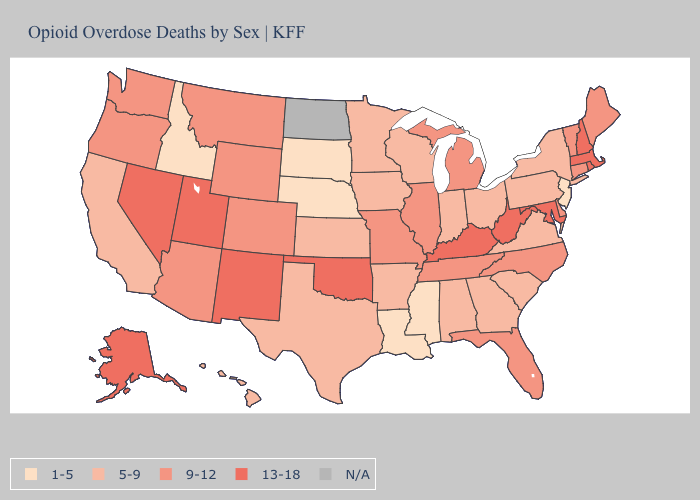What is the lowest value in states that border Utah?
Be succinct. 1-5. What is the lowest value in the Northeast?
Be succinct. 1-5. Which states have the lowest value in the MidWest?
Answer briefly. Nebraska, South Dakota. What is the value of Alaska?
Short answer required. 13-18. What is the value of Mississippi?
Quick response, please. 1-5. What is the lowest value in states that border Delaware?
Write a very short answer. 1-5. What is the value of Florida?
Keep it brief. 9-12. What is the value of Tennessee?
Give a very brief answer. 9-12. What is the lowest value in the Northeast?
Give a very brief answer. 1-5. Name the states that have a value in the range 1-5?
Concise answer only. Idaho, Louisiana, Mississippi, Nebraska, New Jersey, South Dakota. Name the states that have a value in the range 5-9?
Quick response, please. Alabama, Arkansas, California, Georgia, Hawaii, Indiana, Iowa, Kansas, Minnesota, New York, Ohio, Pennsylvania, South Carolina, Texas, Virginia, Wisconsin. What is the lowest value in the USA?
Answer briefly. 1-5. Does California have the highest value in the West?
Be succinct. No. Is the legend a continuous bar?
Quick response, please. No. Does the map have missing data?
Answer briefly. Yes. 